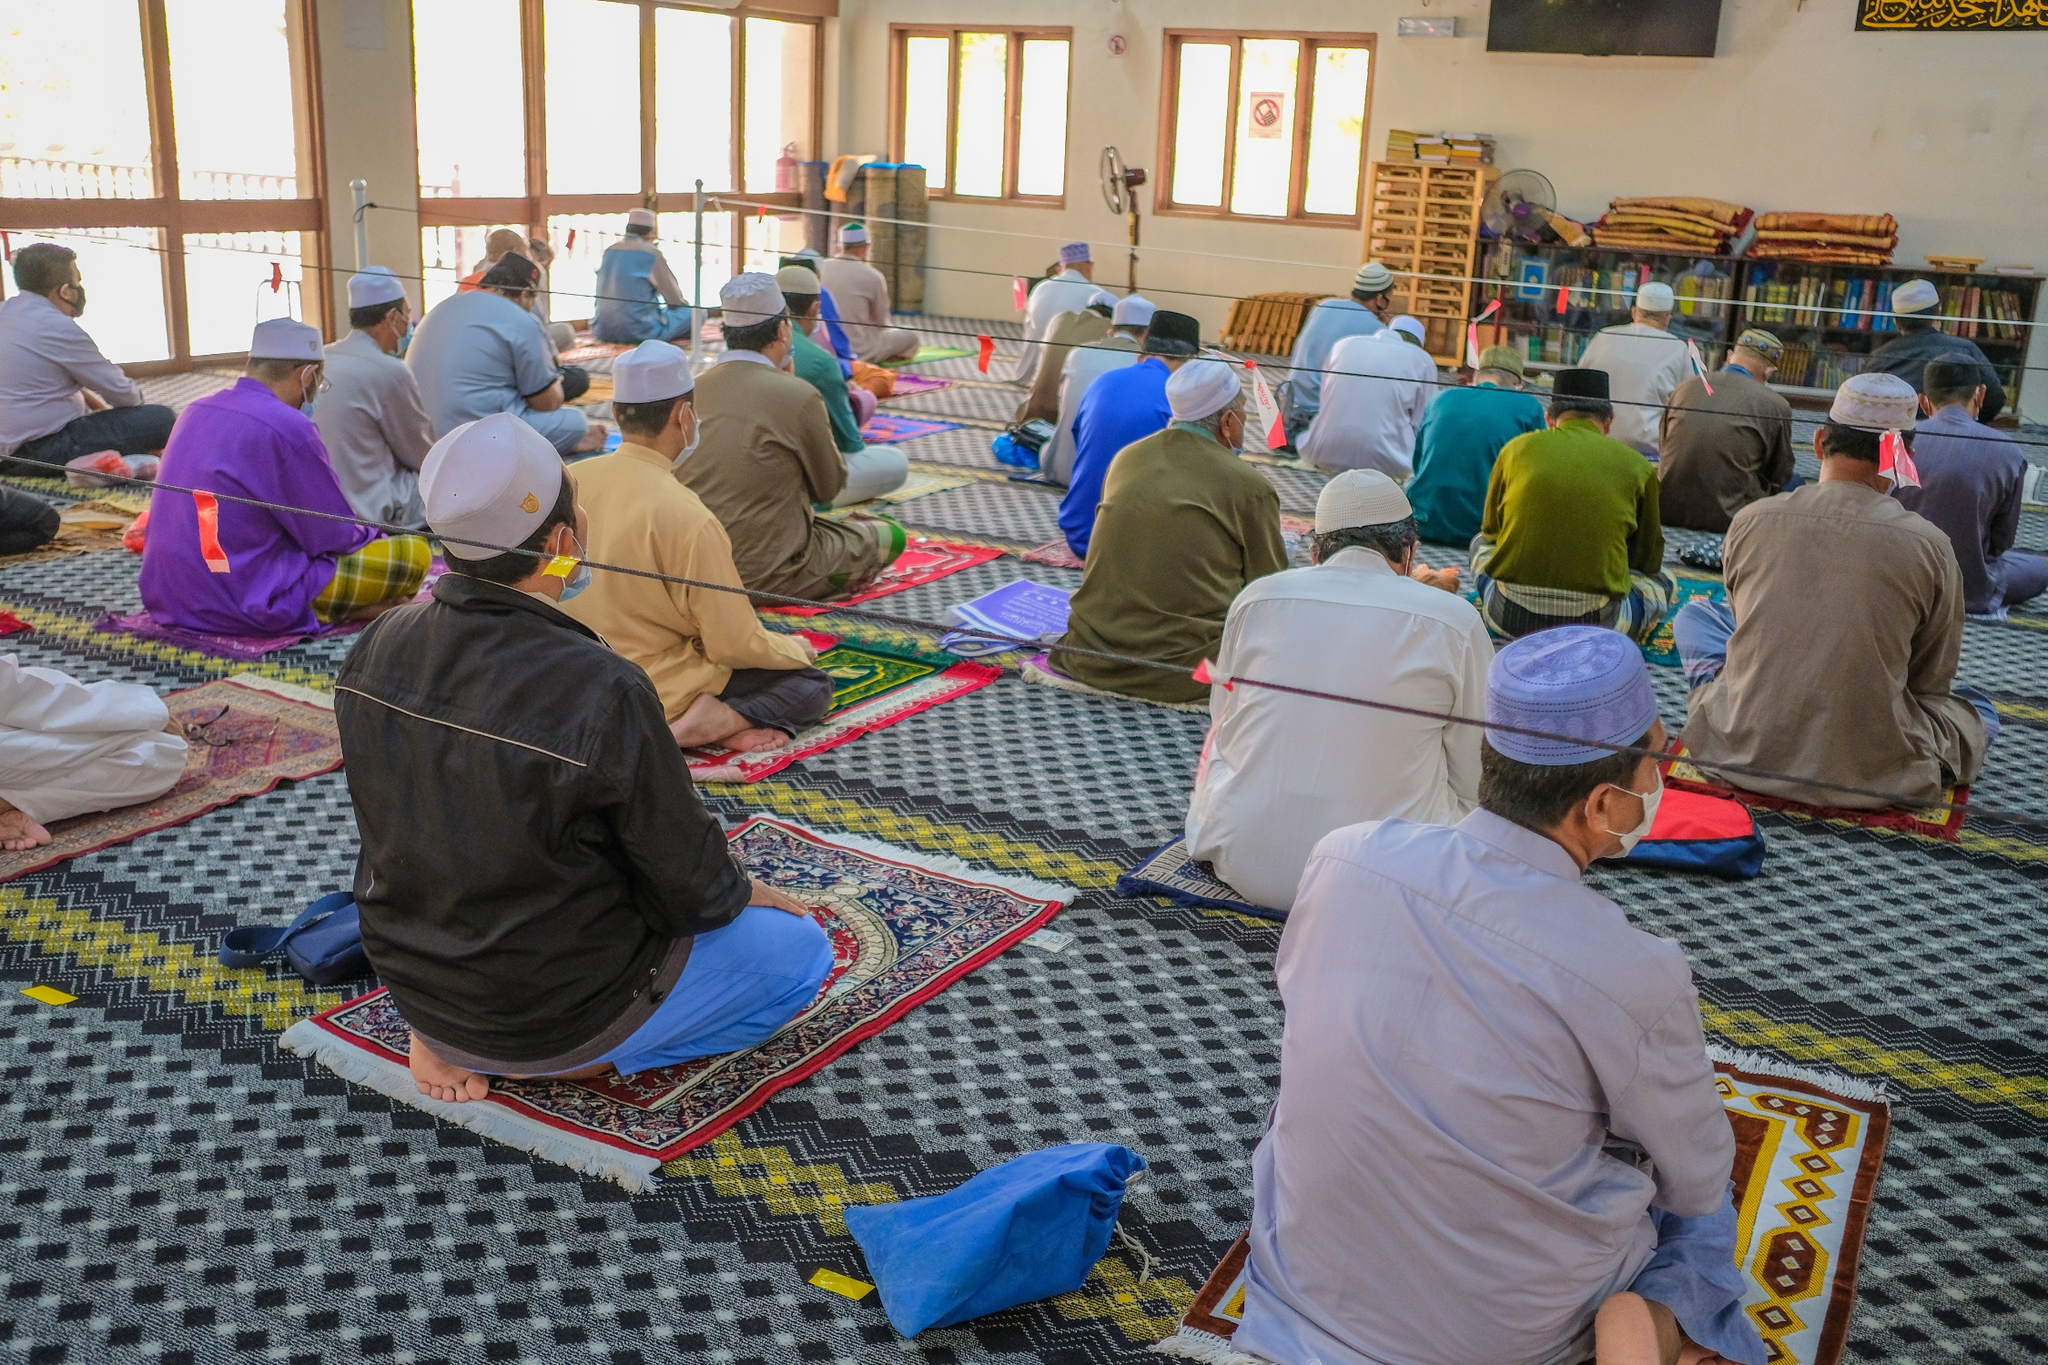What is the significance of the way people are seated in the mosque? In mosques, it is customary for people to sit and pray facing the Qibla, which is the direction of the Kaaba in Mecca. This uniform alignment during prayer promotes a sense of unity and equality among the congregants, as everyone, regardless of status or wealth, stands shoulder to shoulder in the same direction. The orderly arrangement also aids in accommodating a large number of worshippers efficiently within the available space. 